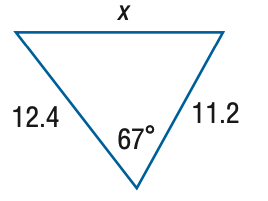Answer the mathemtical geometry problem and directly provide the correct option letter.
Question: Find x. Round the side measure to the nearest tenth.
Choices: A: 6.5 B: 13.1 C: 26.1 D: 52.3 B 